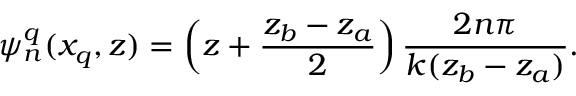<formula> <loc_0><loc_0><loc_500><loc_500>\psi _ { n } ^ { q } ( x _ { q } , z ) = \left ( z + \frac { z _ { b } - z _ { a } } { 2 } \right ) \frac { 2 n \pi } { k ( z _ { b } - z _ { a } ) } .</formula> 